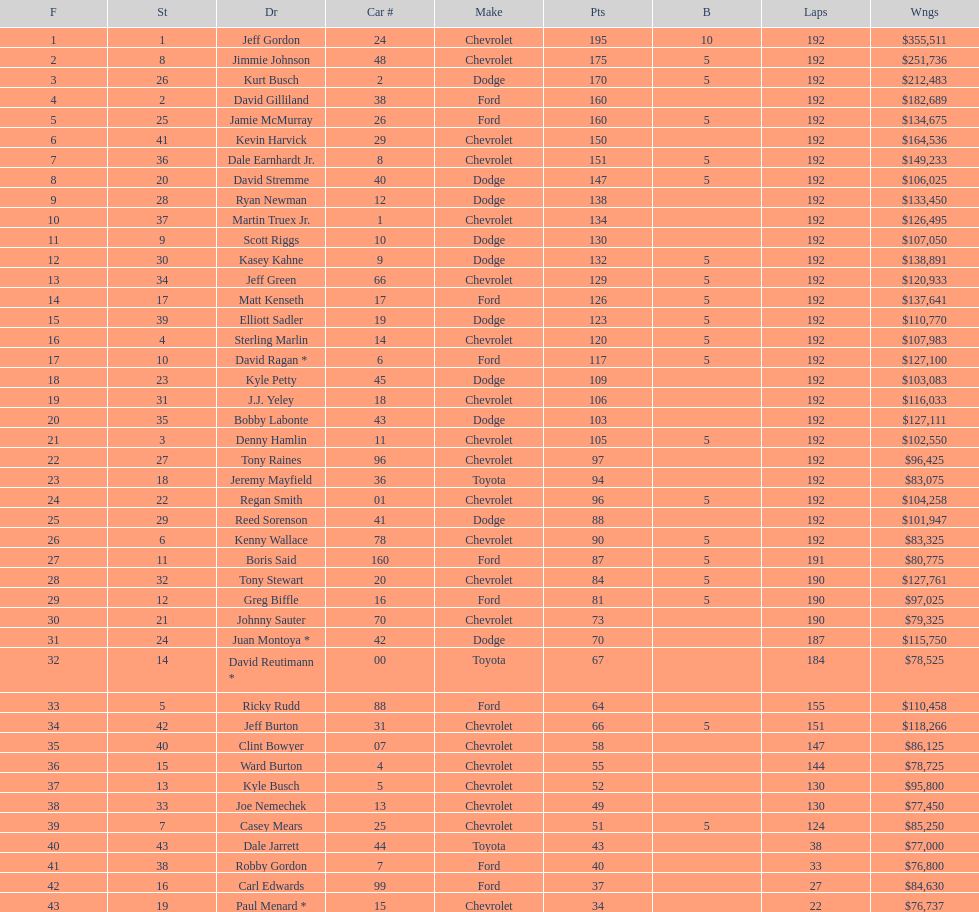How many drivers earned no bonus for this race? 23. 